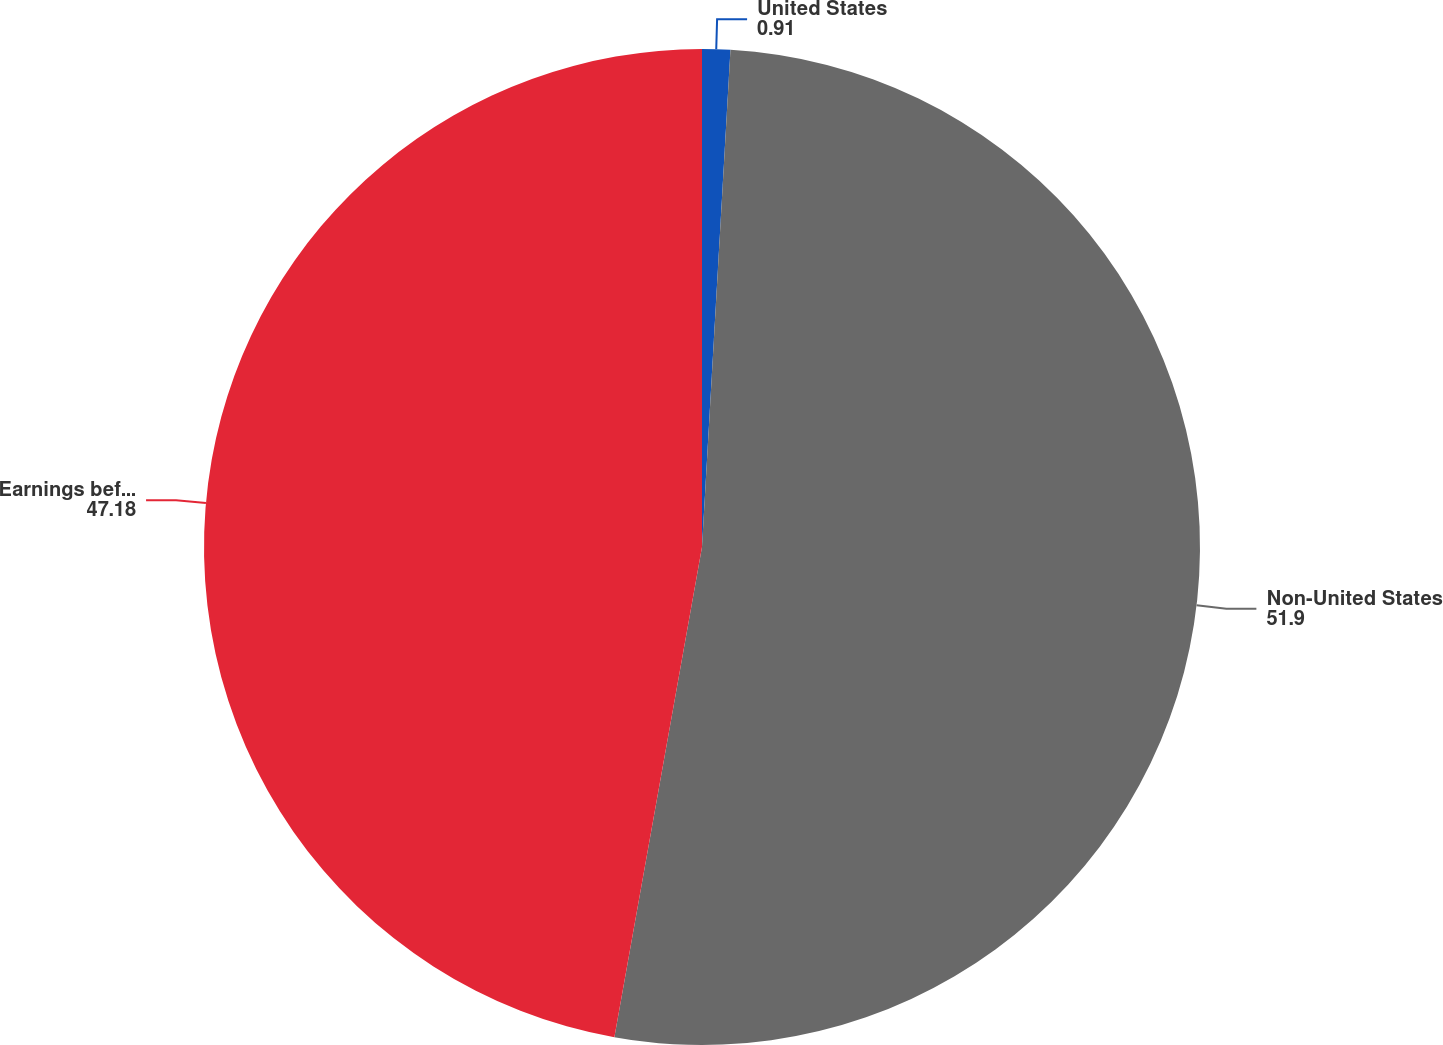Convert chart to OTSL. <chart><loc_0><loc_0><loc_500><loc_500><pie_chart><fcel>United States<fcel>Non-United States<fcel>Earnings before taxes<nl><fcel>0.91%<fcel>51.9%<fcel>47.18%<nl></chart> 